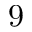<formula> <loc_0><loc_0><loc_500><loc_500>9</formula> 